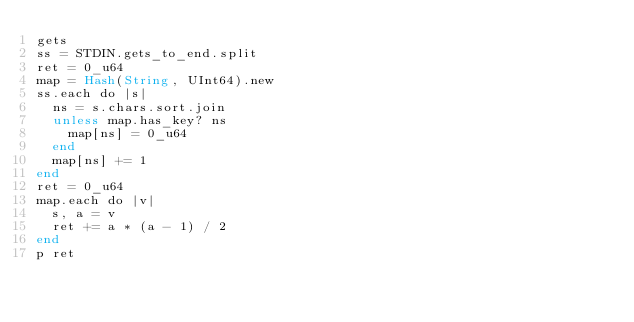Convert code to text. <code><loc_0><loc_0><loc_500><loc_500><_Crystal_>gets
ss = STDIN.gets_to_end.split
ret = 0_u64
map = Hash(String, UInt64).new
ss.each do |s|
  ns = s.chars.sort.join
  unless map.has_key? ns
    map[ns] = 0_u64
  end
  map[ns] += 1
end
ret = 0_u64
map.each do |v|
  s, a = v
  ret += a * (a - 1) / 2
end
p ret</code> 